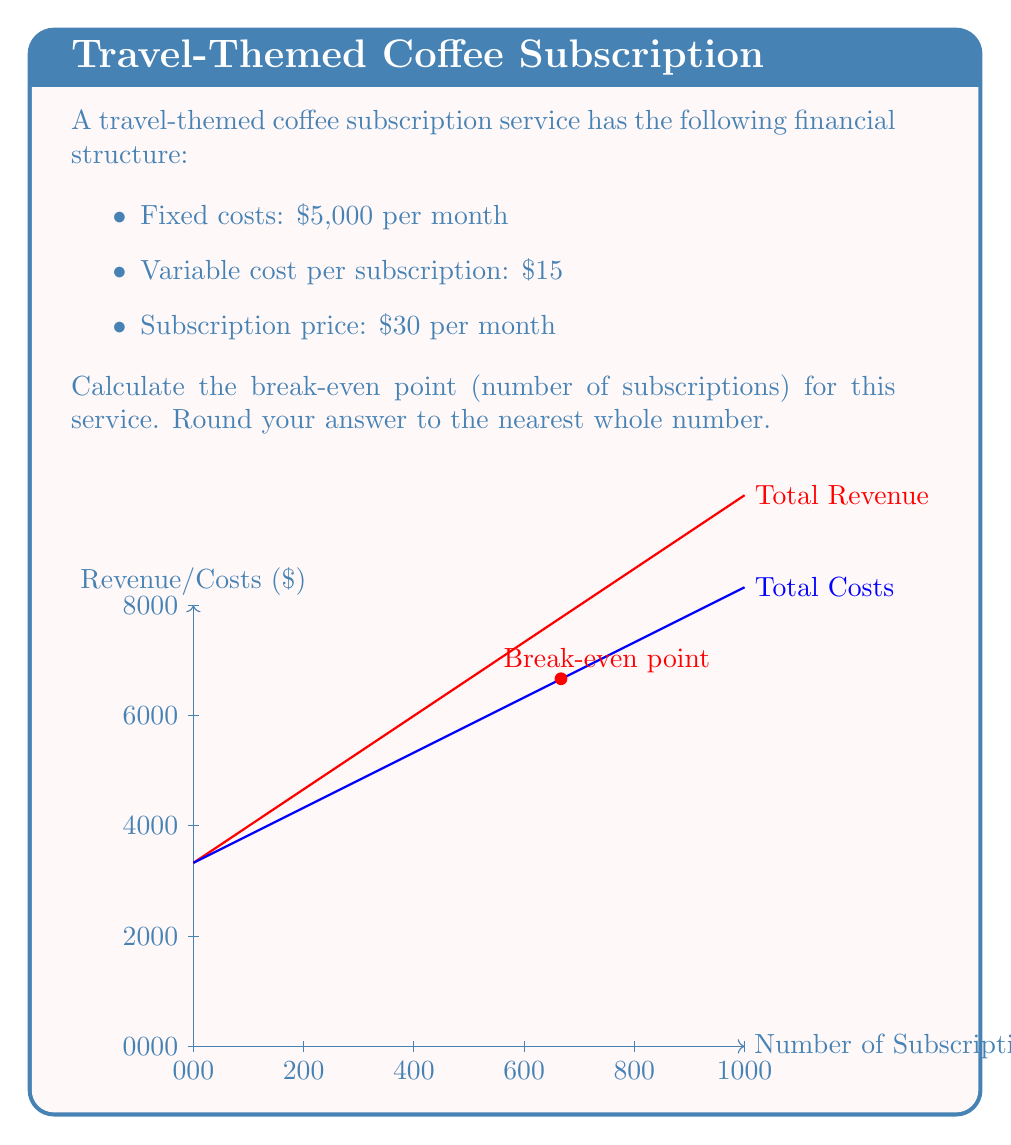Can you answer this question? To calculate the break-even point, we need to find the number of subscriptions where total revenue equals total costs.

Let $x$ be the number of subscriptions.

1. Express total revenue (TR) as a function of $x$:
   $$TR = 30x$$

2. Express total costs (TC) as a function of $x$:
   $$TC = 5000 + 15x$$

3. At the break-even point, TR = TC:
   $$30x = 5000 + 15x$$

4. Solve for $x$:
   $$15x = 5000$$
   $$x = \frac{5000}{15} = 333.33$$

5. Round to the nearest whole number:
   $$x \approx 333$$

Therefore, the break-even point is 333 subscriptions.
Answer: 333 subscriptions 